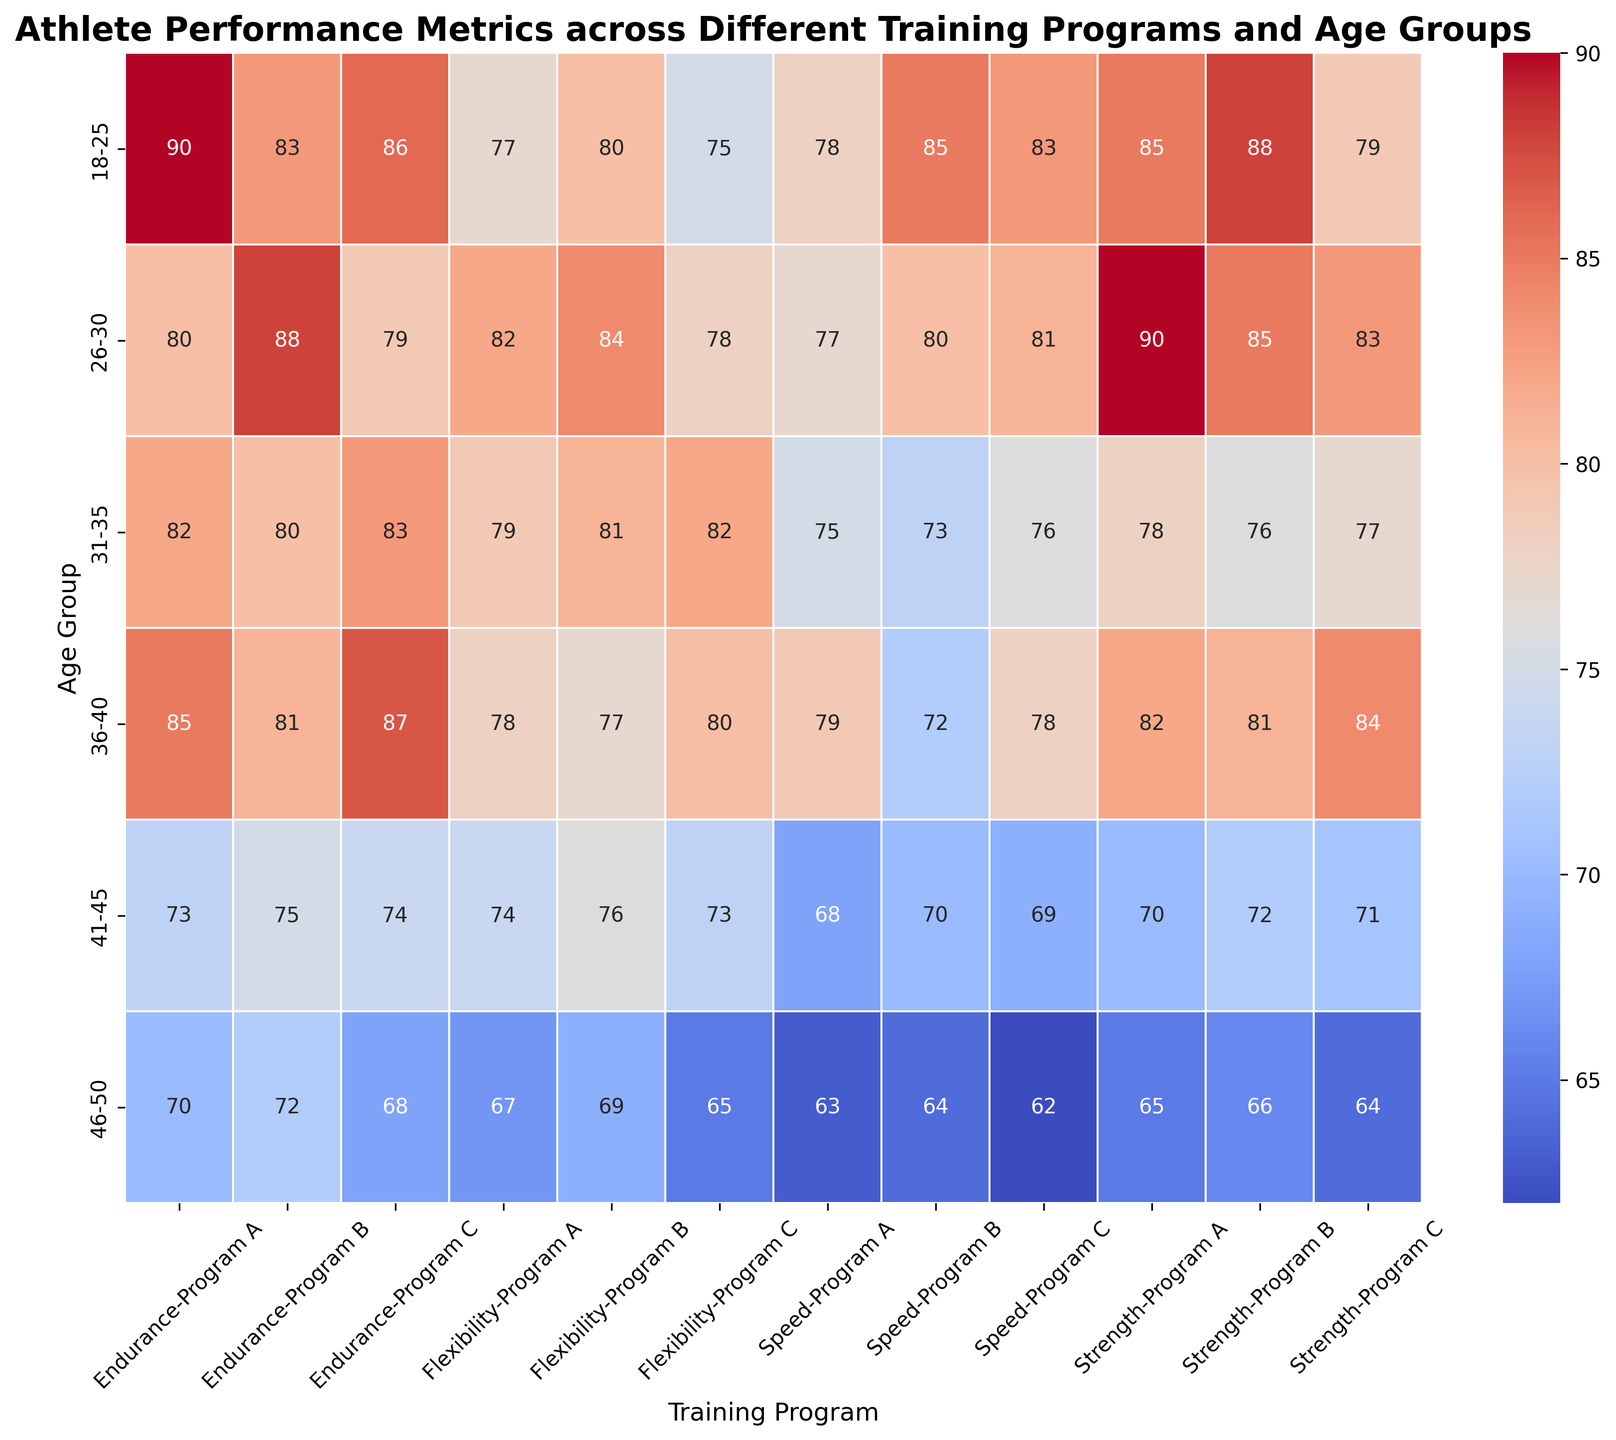Which age group has the highest average strength in Program A? To find the highest average strength in Program A across different age groups, look at the cells under 'Strength' column for 'Program A' and compare their values. The highest value will indicate the required age group.
Answer: 26-30 Which training program has the lowest flexibility in the 41-45 age group? To determine the training program with the lowest flexibility for the 41-45 age group, look at the cells under 'Flexibility' row for 41-45 age group and find the minimum value.
Answer: Program C What is the difference in average endurance between ages 31-35 and 46-50 for Program B? First, locate the values for average endurance in the 31-35 and 46-50 age groups under Program B. Then, subtract the latter value from the former to determine the difference.
Answer: 8 Which age group exhibits the most consistent performance across all four metrics in Program C? Consistency can be interpreted by the smallest range (max-min) of values. Examine the values of 'Strength', 'Speed', 'Endurance', and 'Flexibility' for each age group in Program C, calculate their ranges, and identify the smallest one.
Answer: 41-45 Which training program and age group combination has the highest speed value? To find this, identify the max speed value in the 'Speed' rows across all training programs and age groups, then locate its corresponding cells.
Answer: 18-25, Program B Compare the overall flexibility trends across each training program for different age groups. Which pattern do you observe? By observing the Flexibility values across all age groups for each program, you notice the general increasing or decreasing trends and patterns. Summarize the observed trend for each training program.
Answer: Generally consistent trends with slight variations between 68-84 What is the average speed for athletes aged 36-40 across all training programs? Locate the Speed values for the 36-40 age group across all programs. Then, sum all these values and divide by the number of training programs to find the average.
Answer: 76.3 Which metric shows the most variability across programs for the 18-25 age group? To find the metric with the most variability, calculate the range (max-min) for 'Strength', 'Speed', 'Endurance', and 'Flexibility' for the 18-25 age group across all training programs, and identify the largest one.
Answer: Strength How does the average endurance for the 26-30 age group in Program A compare to the same metric in Program B? Locate average endurance values for the 26-30 age group in Program A and B and compare these values to see which one is higher.
Answer: Program B (88 vs 80) Which age group and training program combination has the darkest shade of blue in the heatmap? Look for the darkest shade of blue (indicating the lowest value) across all combinations of age groups and training programs. Identify the corresponding cell.
Answer: 46-50, Program C, Strength (lowest) 